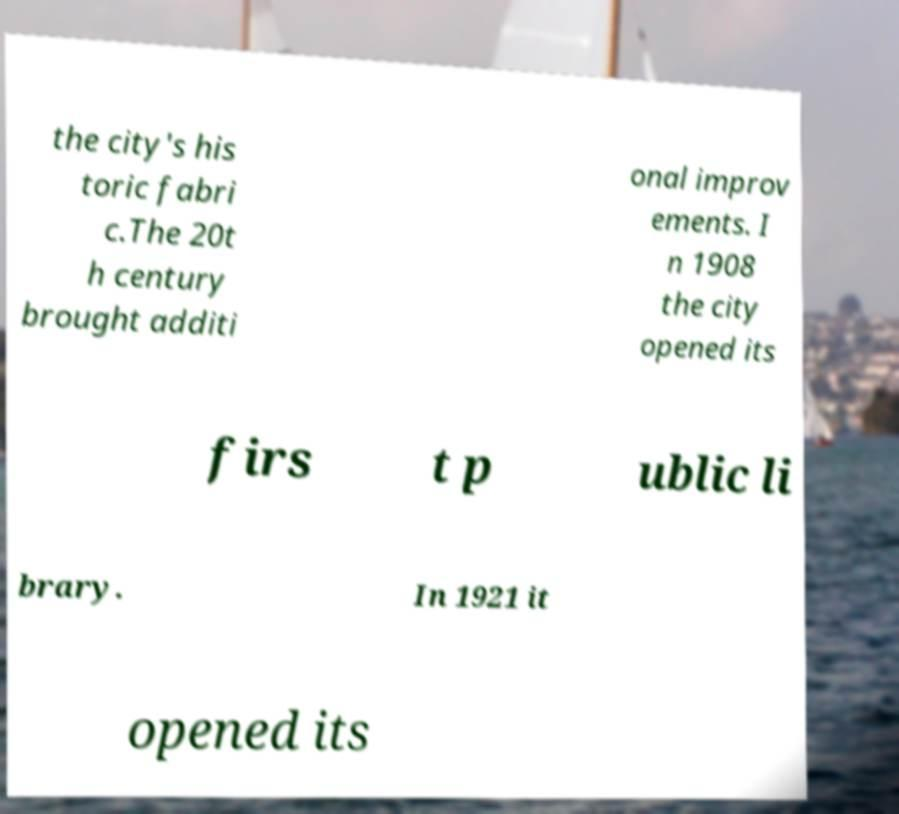Could you extract and type out the text from this image? the city's his toric fabri c.The 20t h century brought additi onal improv ements. I n 1908 the city opened its firs t p ublic li brary. In 1921 it opened its 